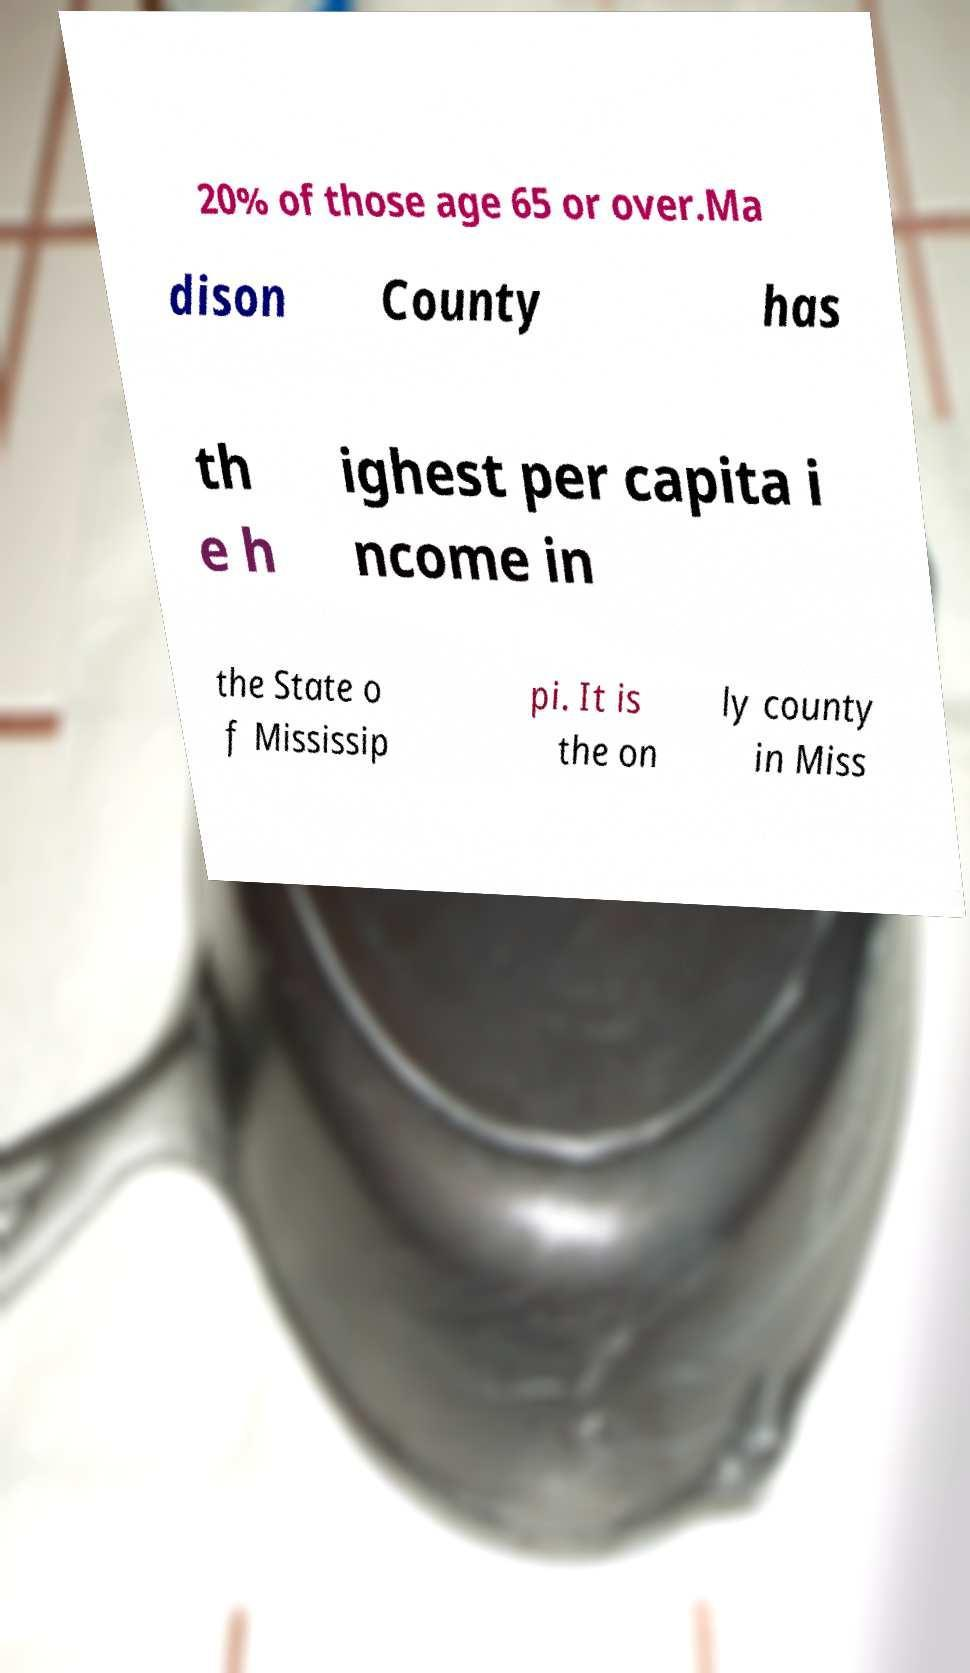Please read and relay the text visible in this image. What does it say? 20% of those age 65 or over.Ma dison County has th e h ighest per capita i ncome in the State o f Mississip pi. It is the on ly county in Miss 